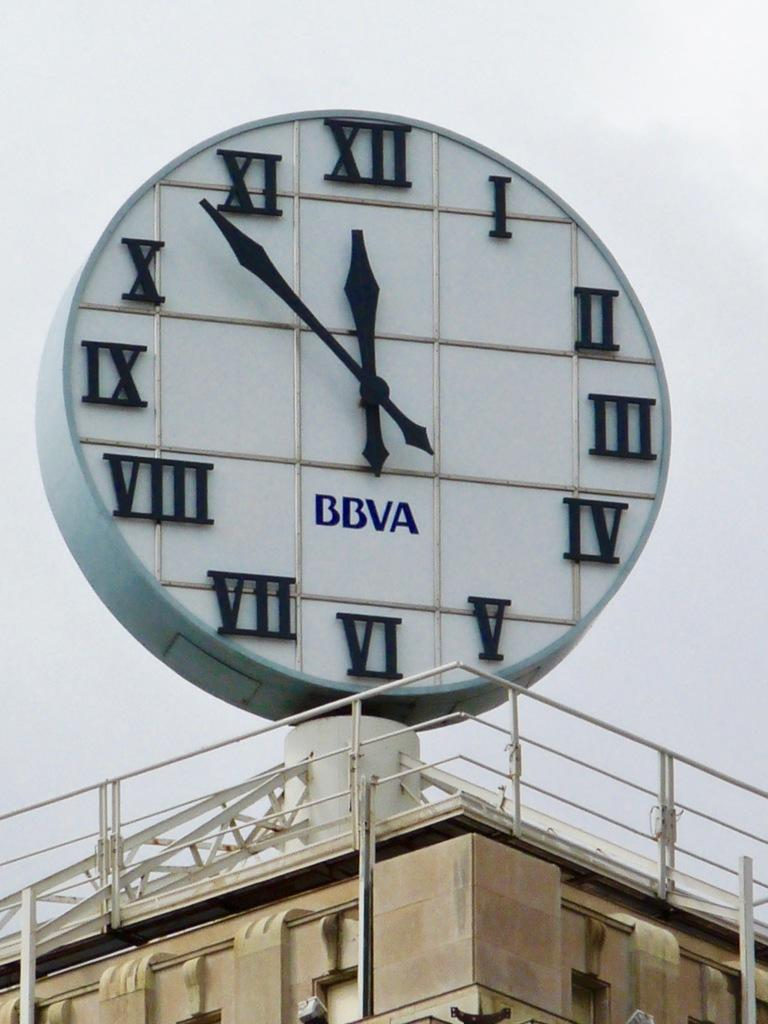Provide a one-sentence caption for the provided image. A big BBVA outdoor clack show the time of 11:53. 